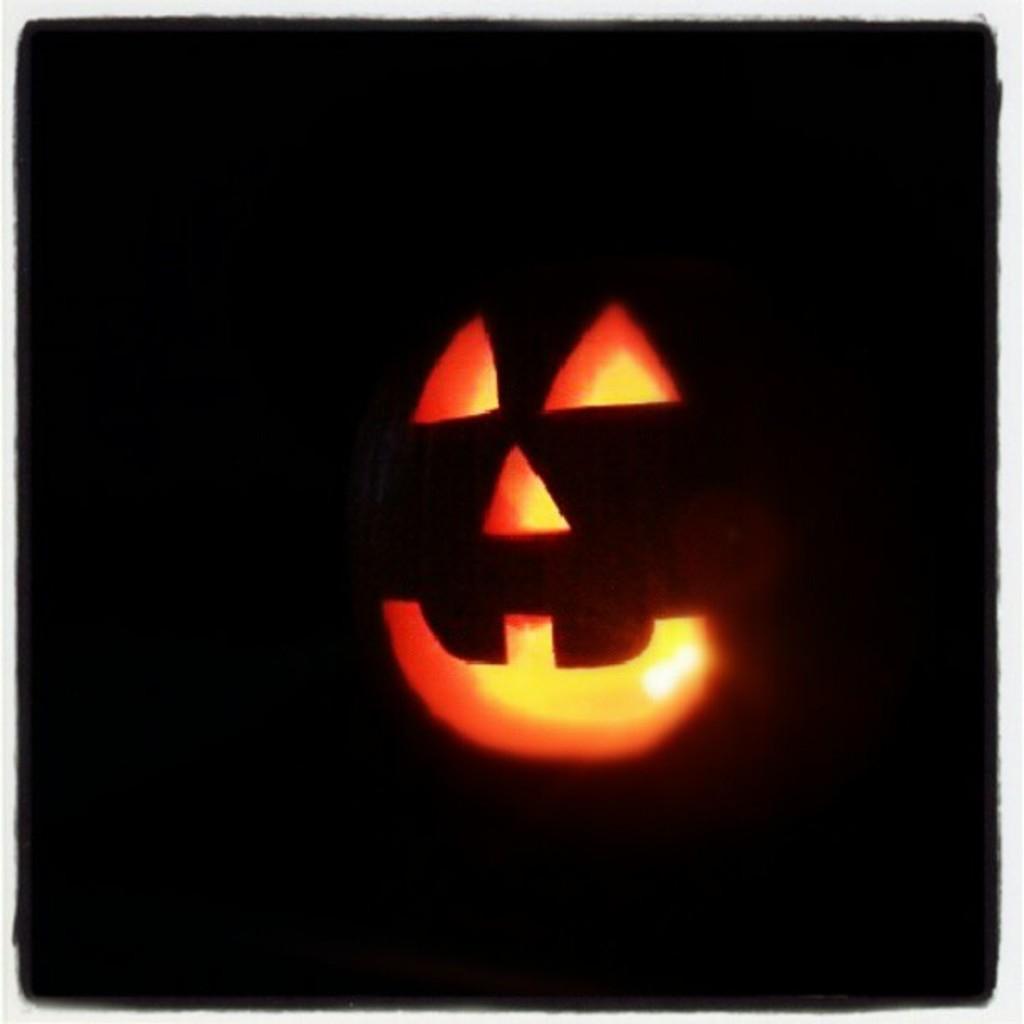Can you describe this image briefly? In this image we can see a pumpkin. There is a light in the pumpkin. There is a dark background in the image. 